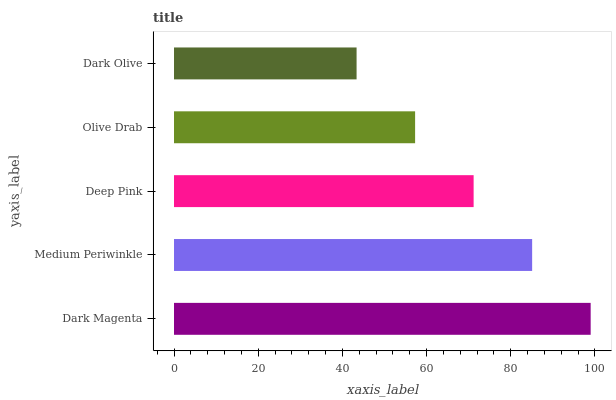Is Dark Olive the minimum?
Answer yes or no. Yes. Is Dark Magenta the maximum?
Answer yes or no. Yes. Is Medium Periwinkle the minimum?
Answer yes or no. No. Is Medium Periwinkle the maximum?
Answer yes or no. No. Is Dark Magenta greater than Medium Periwinkle?
Answer yes or no. Yes. Is Medium Periwinkle less than Dark Magenta?
Answer yes or no. Yes. Is Medium Periwinkle greater than Dark Magenta?
Answer yes or no. No. Is Dark Magenta less than Medium Periwinkle?
Answer yes or no. No. Is Deep Pink the high median?
Answer yes or no. Yes. Is Deep Pink the low median?
Answer yes or no. Yes. Is Dark Magenta the high median?
Answer yes or no. No. Is Olive Drab the low median?
Answer yes or no. No. 